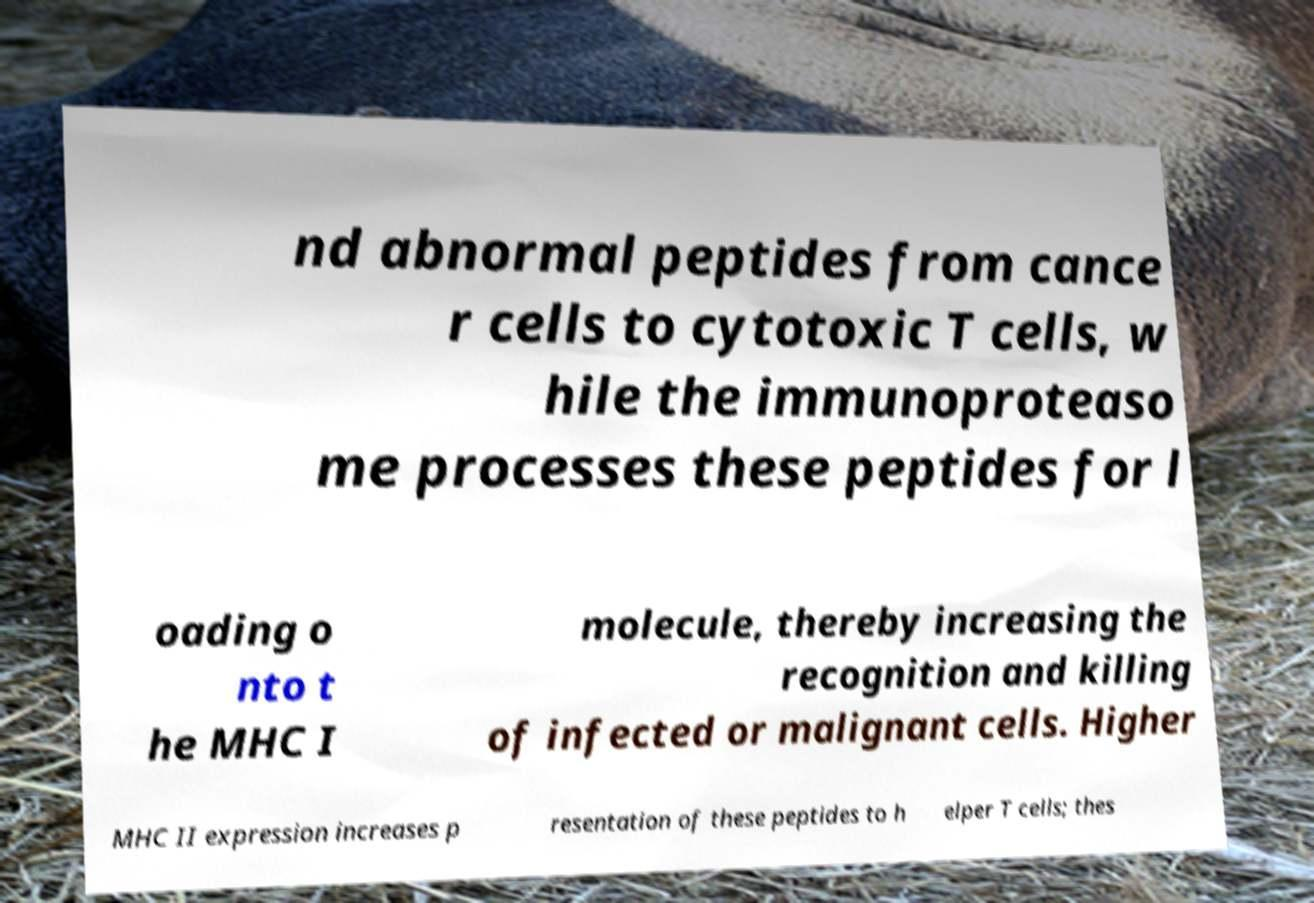Could you extract and type out the text from this image? nd abnormal peptides from cance r cells to cytotoxic T cells, w hile the immunoproteaso me processes these peptides for l oading o nto t he MHC I molecule, thereby increasing the recognition and killing of infected or malignant cells. Higher MHC II expression increases p resentation of these peptides to h elper T cells; thes 